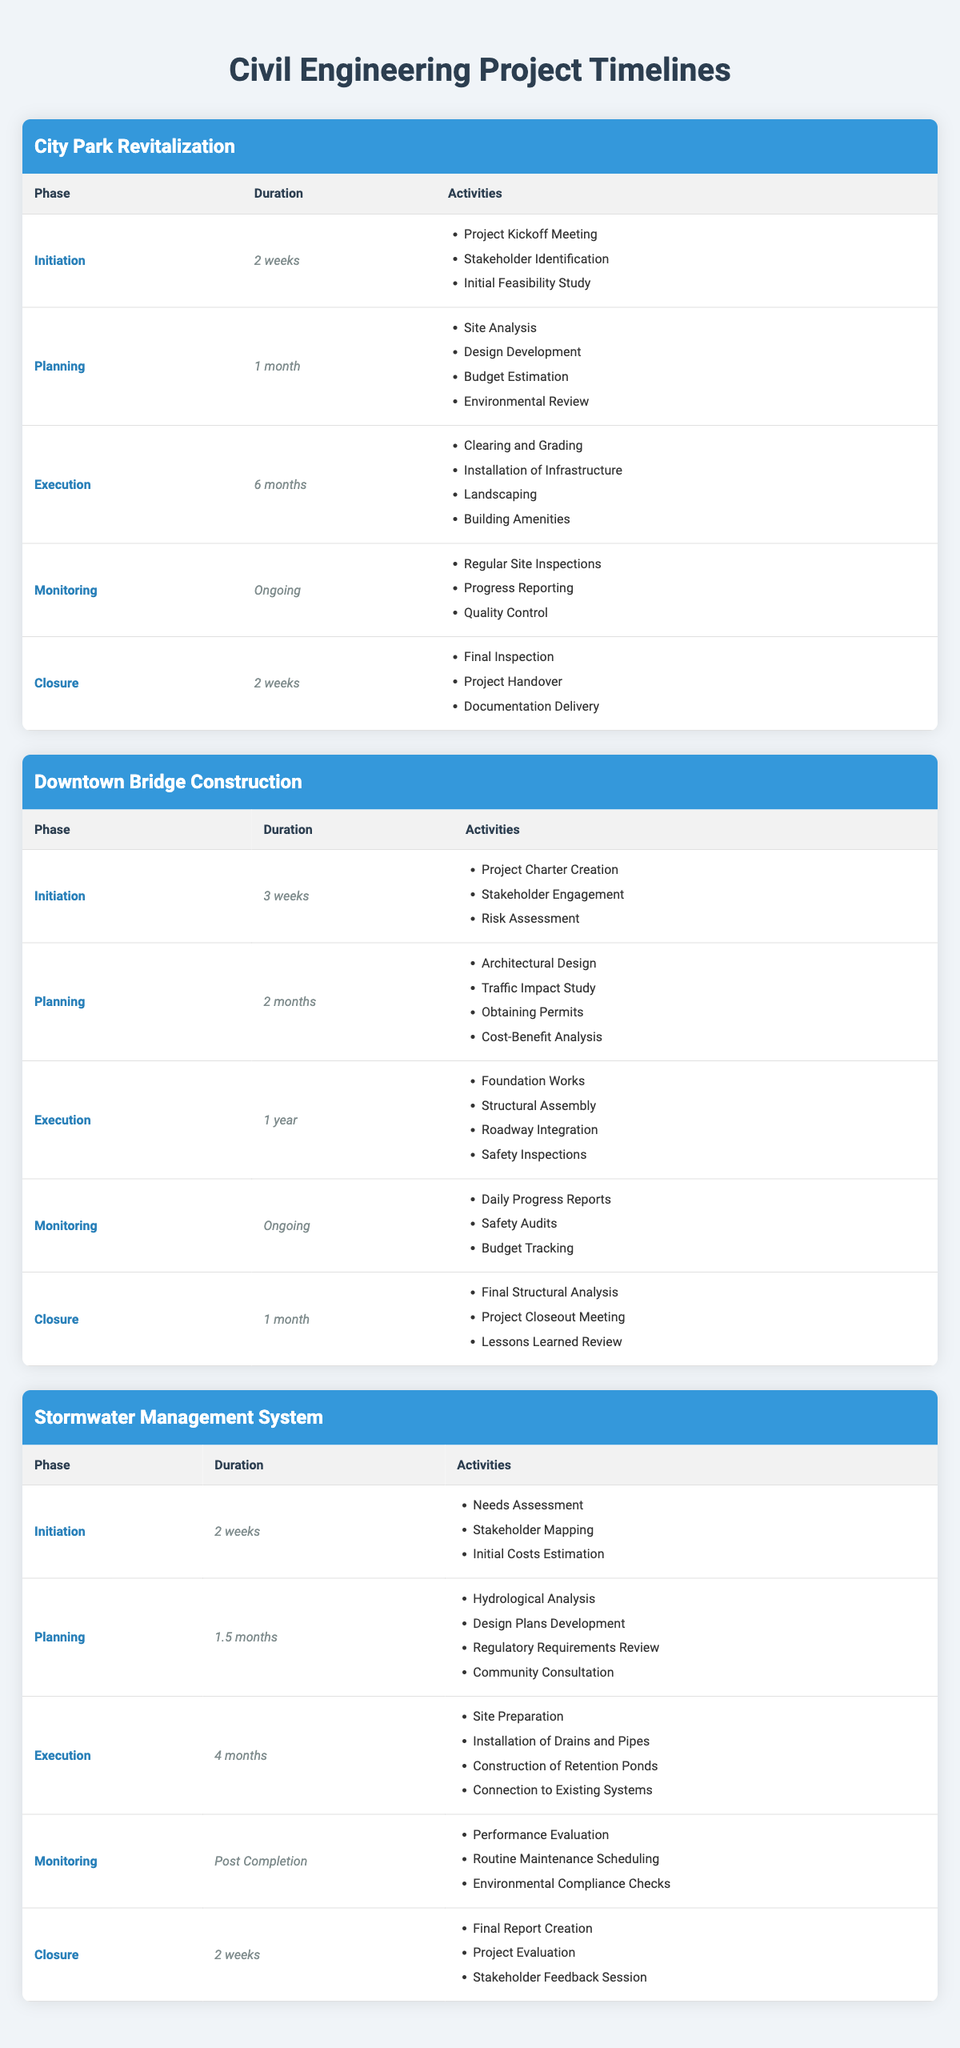What is the duration of the Initiation phase for the City Park Revitalization project? The table for the City Park Revitalization project states that the duration of the Initiation phase is "2 weeks."
Answer: 2 weeks How many phases are there in the Downtown Bridge Construction project? The Downtown Bridge Construction project lists five phases: Initiation, Planning, Execution, Monitoring, and Closure.
Answer: 5 phases What activities are included in the Planning phase of the Stormwater Management System project? The Planning phase includes four activities: Hydrological Analysis, Design Plans Development, Regulatory Requirements Review, and Community Consultation as shown in the table.
Answer: Hydrological Analysis, Design Plans Development, Regulatory Requirements Review, Community Consultation Which project has the longest Execution phase duration? The Execution phase of the Downtown Bridge Construction project lasts "1 year," which is longer than the Execution phases of the other projects (City Park Revitalization has 6 months and Stormwater Management System has 4 months).
Answer: Downtown Bridge Construction Is the Monitoring phase for all three projects ongoing? The Monitoring phase for City Park Revitalization and Downtown Bridge Construction is ongoing, while the Stormwater Management System project specifies "Post Completion," indicating it does not qualify as ongoing.
Answer: No What is the total duration of the Planning phases for all three projects combined? The Planning phase durations are "1 month" for City Park Revitalization, "2 months" for Downtown Bridge Construction, and "1.5 months" for Stormwater Management System. Converted to weeks: 1 month = 4 weeks, so total is 4 + 8 + 6 = 18 weeks or 4.5 months.
Answer: 4.5 months Which project has a Closure phase duration of 2 weeks? The City Park Revitalization project and the Stormwater Management System project both have a Closure phase duration of "2 weeks," as listed in their respective tables.
Answer: City Park Revitalization and Stormwater Management System In the Downtown Bridge Construction, how many activities are listed for the Execution phase? The Execution phase of the Downtown Bridge Construction project has four activities listed: Foundation Works, Structural Assembly, Roadway Integration, and Safety Inspections.
Answer: 4 activities What is the difference in duration between the Execution phase of the City Park Revitalization and Stormwater Management System? The Execution phase of the City Park Revitalization lasts "6 months," while the Stormwater Management System lasts "4 months." The difference is 6 months - 4 months = 2 months.
Answer: 2 months 